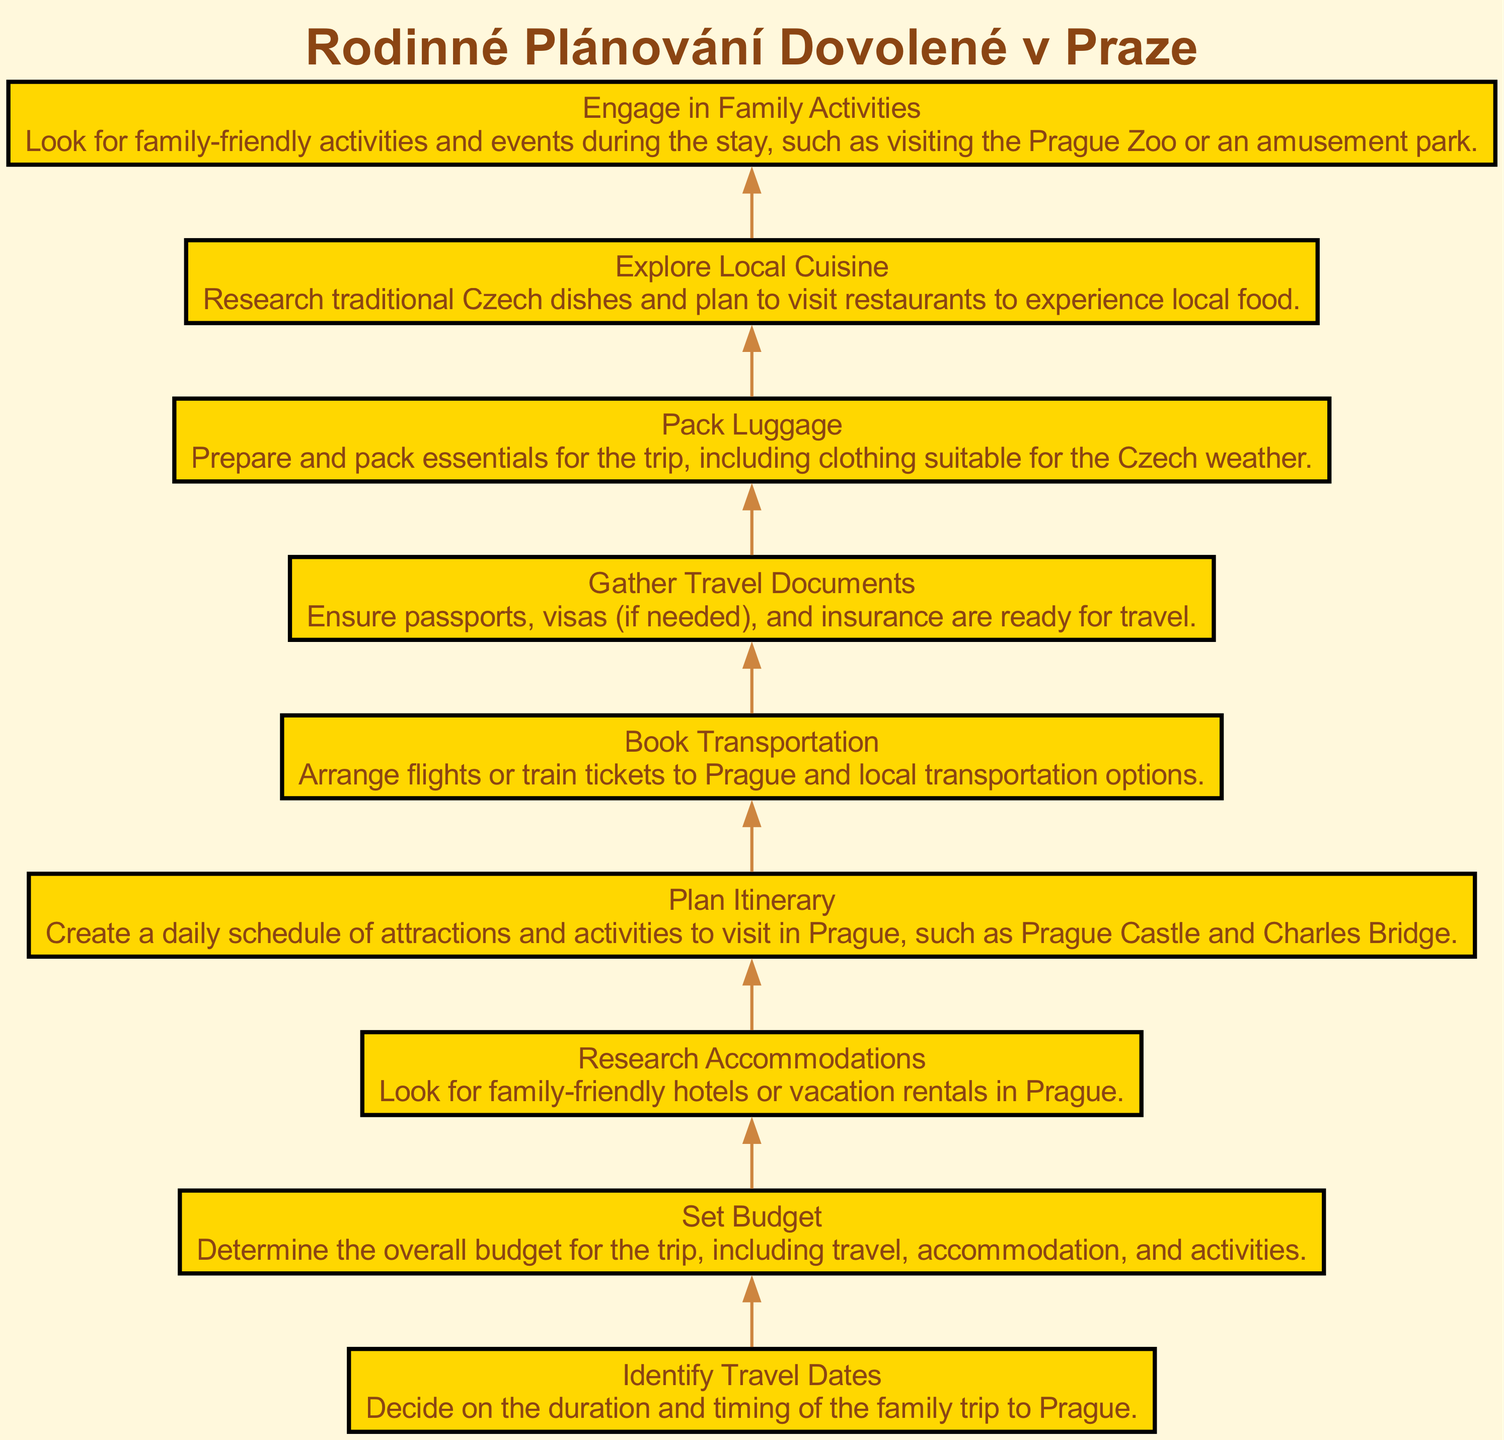What is the first step in the vacation planning process? The first step in the vacation planning process is "Identify Travel Dates," which involves deciding on the duration and timing of the family trip to Prague.
Answer: Identify Travel Dates How many nodes are in the diagram? The diagram includes a total of 9 nodes, representing different steps in the vacation planning process.
Answer: 9 What node comes after "Set Budget"? The node that comes after "Set Budget" is "Research Accommodations," which involves looking for family-friendly hotels or vacation rentals in Prague.
Answer: Research Accommodations What is the last step in the process? The last step in the process is "Engage in Family Activities," which includes looking for family-friendly activities and events during the stay in Prague.
Answer: Engage in Family Activities Which elements are connected directly to "Plan Itinerary"? "Plan Itinerary" is directly connected to "Research Accommodations" (as a prerequisite) and "Book Transportation" (as the next step after planning).
Answer: Research Accommodations, Book Transportation What is the purpose of "Gather Travel Documents"? The purpose of "Gather Travel Documents" is to ensure that passports, visas (if needed), and insurance are ready for travel, which is essential for a smooth trip.
Answer: Ensure passports, visas, and insurance Which step involves exploring local food? The step that involves exploring local food is "Explore Local Cuisine," where traditional Czech dishes are researched and restaurants are planned to visit.
Answer: Explore Local Cuisine How does "Pack Luggage" fit into the overall process? "Pack Luggage" fits into the overall process as one of the last steps, after gathering documents, which indicates it happens shortly before the actual travel to Prague.
Answer: One of the last steps before travel 